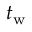<formula> <loc_0><loc_0><loc_500><loc_500>t _ { w }</formula> 